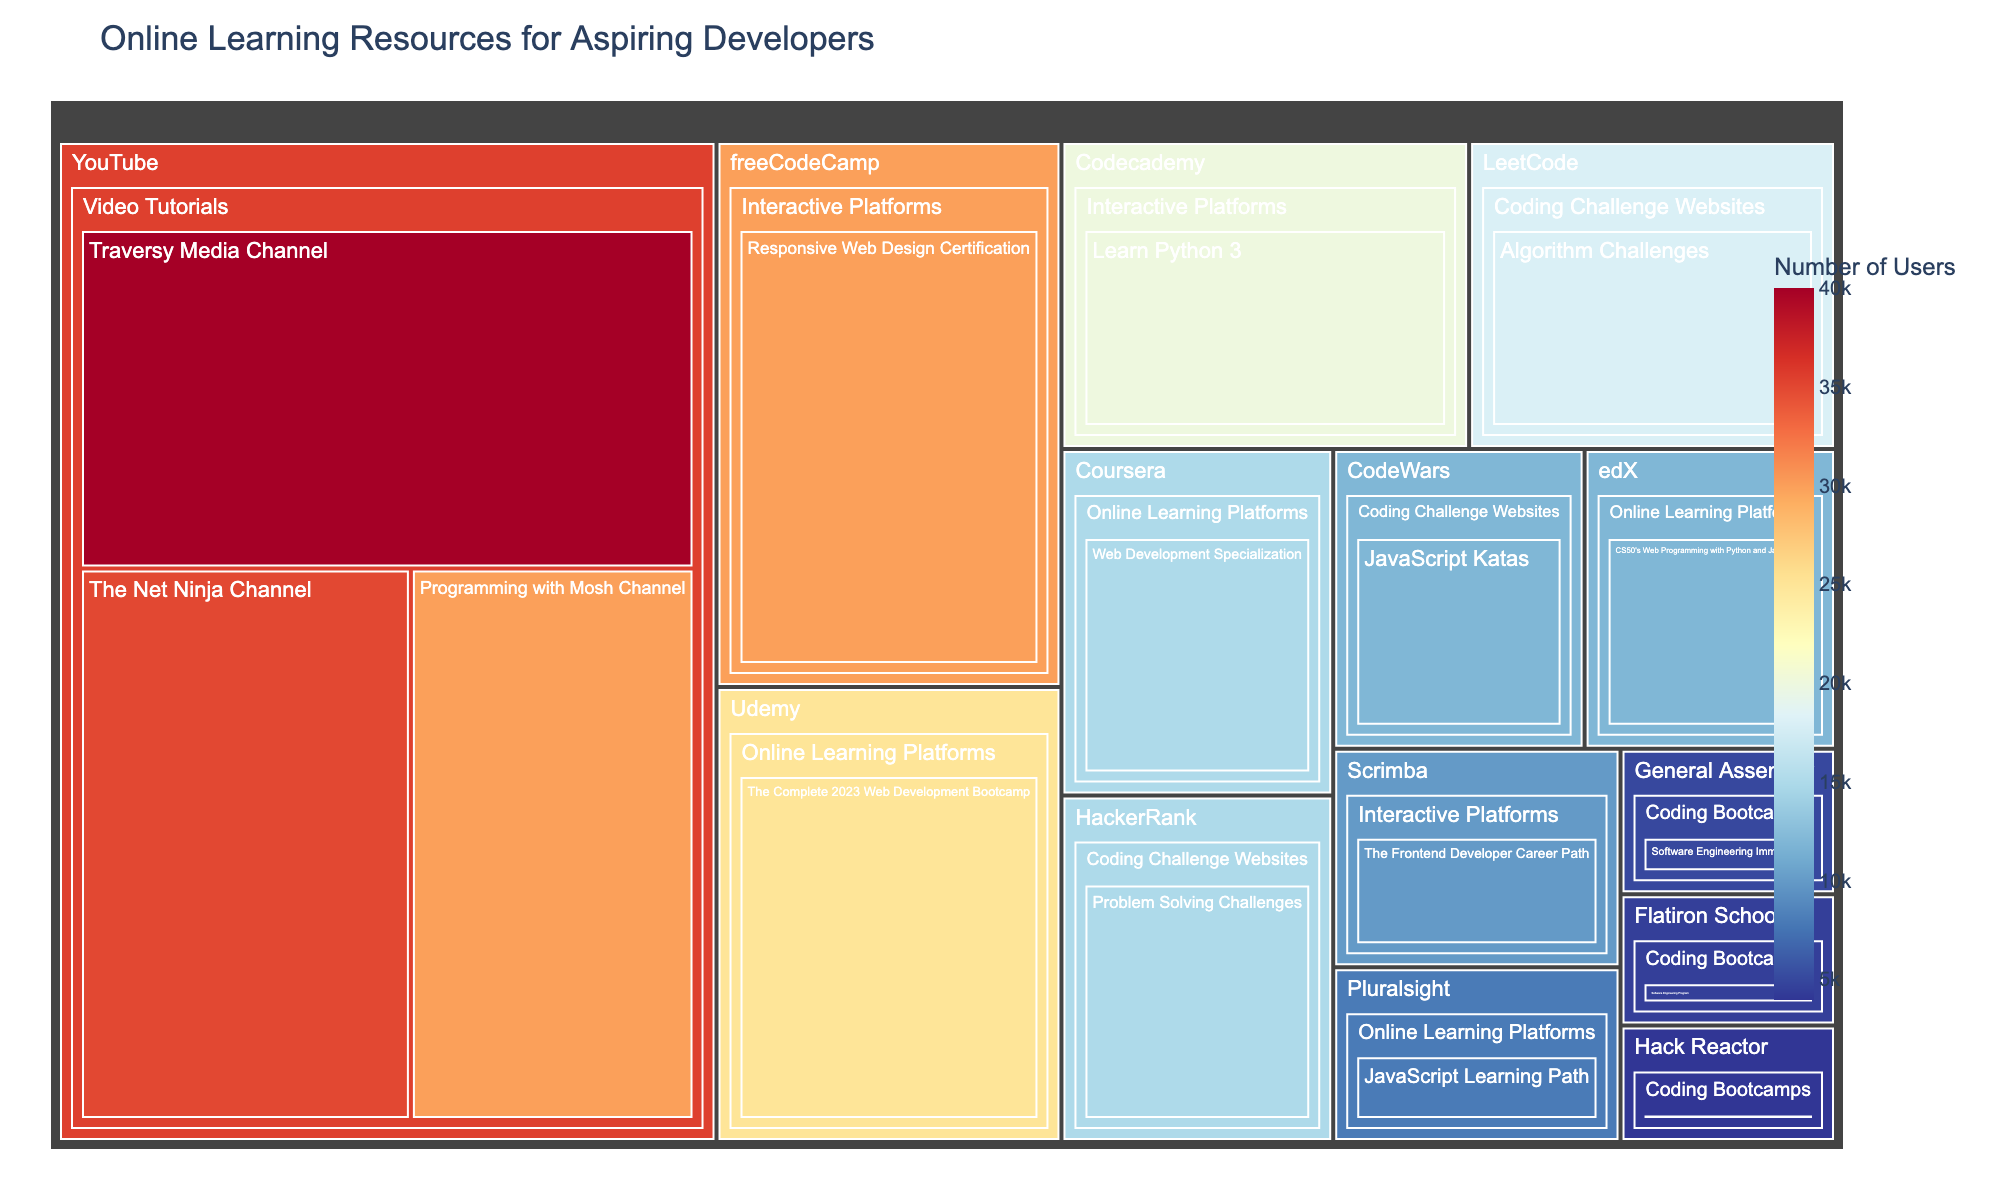What is the title of the treemap? The title is usually displayed at the top of the treemap in a larger and bold font. By looking at the top of the treemap, you can see the text that indicates the title.
Answer: Online Learning Resources for Aspiring Developers How many platforms are included in the treemap? Platforms are represented as the second level in the treemap, grouped under their respective categories. By counting all unique platforms, you can find the answer.
Answer: 10 Which category contains the resource with the highest number of users? By examining the largest individual block in the treemap, observe its label and trace it back to its parent category. The largest block represents the resource with the highest number of users.
Answer: Video Tutorials How many users are there in the "Online Learning Platforms" category in total? Sum the number of users for each resource under the "Online Learning Platforms" category. Resources include Coursera, Udemy, edX, and Pluralsight.
Answer: 60,000 (15,000 + 25,000 + 12,000 + 8,000) Which platform has more users: freeCodeCamp or Codecademy? Locate the blocks representing freeCodeCamp and Codecademy on the treemap, then compare the number of users listed for each. freeCodeCamp has more users (30,000) compared to Codecademy (20,000).
Answer: freeCodeCamp What is the difference in the number of users between the "Traversy Media Channel" and the "Programming with Mosh Channel"? Find the number of users for both resources in the "Video Tutorials" category. Subtract the number of users of the "Programming with Mosh Channel" from the "Traversy Media Channel".
Answer: 10,000 (40,000 - 30,000) Which resource has the smallest number of users in the "Coding Bootcamps" category? Identify the blocks labeled as Coding Bootcamps, then find the smallest block in that category by looking at the user counts. "Hack Reactor, Software Engineering Immersive" has the smallest number of users.
Answer: Hack Reactor, Software Engineering Immersive How many users prefer the "Coding Challenge Websites" category as a whole? Sum the number of users for all resources under the "Coding Challenge Websites" category, including LeetCode, HackerRank, and CodeWars.
Answer: 45,000 (18,000 + 15,000 + 12,000) Compare the number of users of the "General Assembly, Software Engineering Immersive" and "Scrimba, The Frontend Developer Career Path". Which one has more users? Locate these resources in their respective categories. Compare the numbers of users. The "Scrimba, The Frontend Developer Career Path" has more users (10,000 vs. 5,000 for General Assembly).
Answer: Scrimba, The Frontend Developer Career Path What is the combined total of users for all "Video Tutorials" on YouTube? Sum the number of users for all YouTube resources in the "Video Tutorials" category. The resources are Traversy Media Channel, The Net Ninja Channel, and Programming with Mosh Channel.
Answer: 105,000 (40,000 + 35,000 + 30,000) 